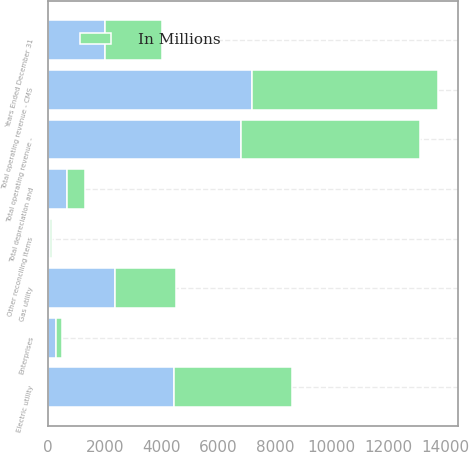<chart> <loc_0><loc_0><loc_500><loc_500><stacked_bar_chart><ecel><fcel>Years Ended December 31<fcel>Electric utility<fcel>Gas utility<fcel>Enterprises<fcel>Other reconciling items<fcel>Total operating revenue - CMS<fcel>Total operating revenue -<fcel>Total depreciation and<nl><fcel>nan<fcel>2014<fcel>4436<fcel>2363<fcel>299<fcel>81<fcel>7179<fcel>6800<fcel>685<nl><fcel>In Millions<fcel>2013<fcel>4173<fcel>2148<fcel>181<fcel>64<fcel>6566<fcel>6321<fcel>628<nl></chart> 